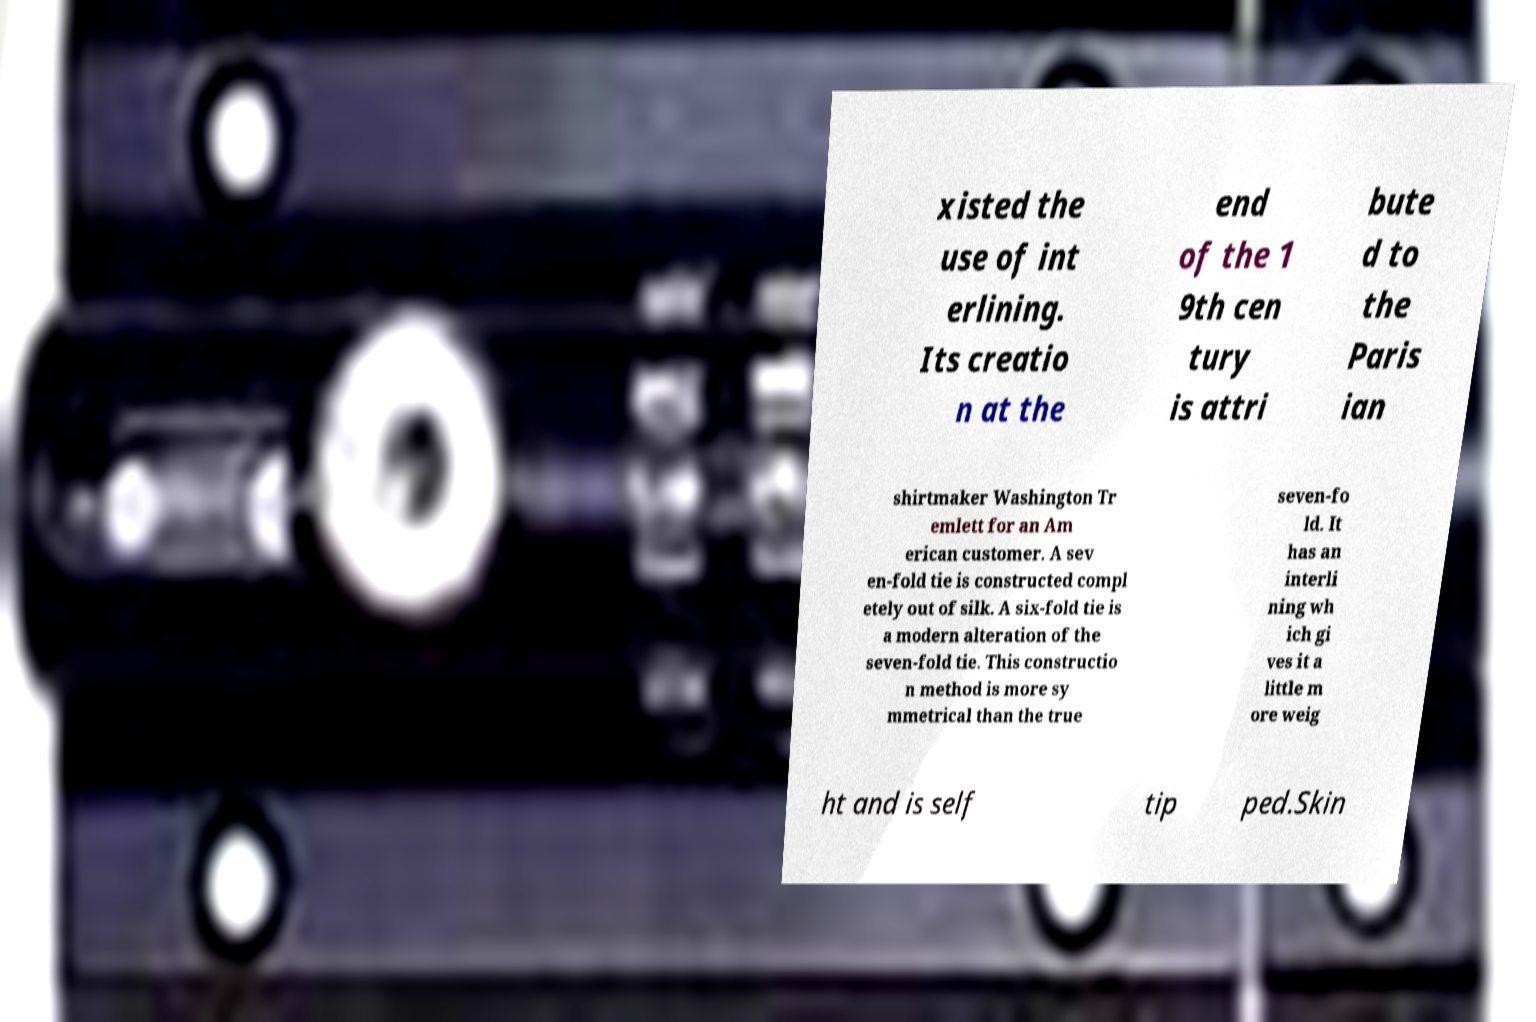There's text embedded in this image that I need extracted. Can you transcribe it verbatim? xisted the use of int erlining. Its creatio n at the end of the 1 9th cen tury is attri bute d to the Paris ian shirtmaker Washington Tr emlett for an Am erican customer. A sev en-fold tie is constructed compl etely out of silk. A six-fold tie is a modern alteration of the seven-fold tie. This constructio n method is more sy mmetrical than the true seven-fo ld. It has an interli ning wh ich gi ves it a little m ore weig ht and is self tip ped.Skin 